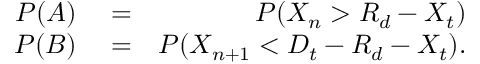<formula> <loc_0><loc_0><loc_500><loc_500>\begin{array} { r l r } { P ( A ) } & = } & { P ( X _ { n } > R _ { d } - X _ { t } ) } \\ { P ( B ) } & = } & { P ( X _ { n + 1 } < D _ { t } - R _ { d } - X _ { t } ) . } \end{array}</formula> 